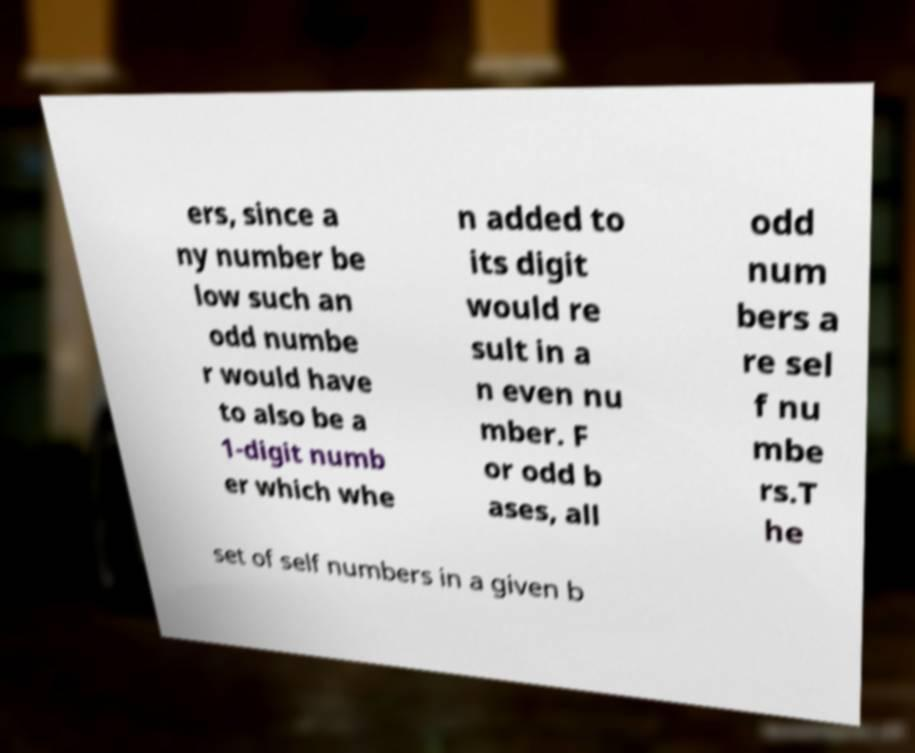Please read and relay the text visible in this image. What does it say? ers, since a ny number be low such an odd numbe r would have to also be a 1-digit numb er which whe n added to its digit would re sult in a n even nu mber. F or odd b ases, all odd num bers a re sel f nu mbe rs.T he set of self numbers in a given b 